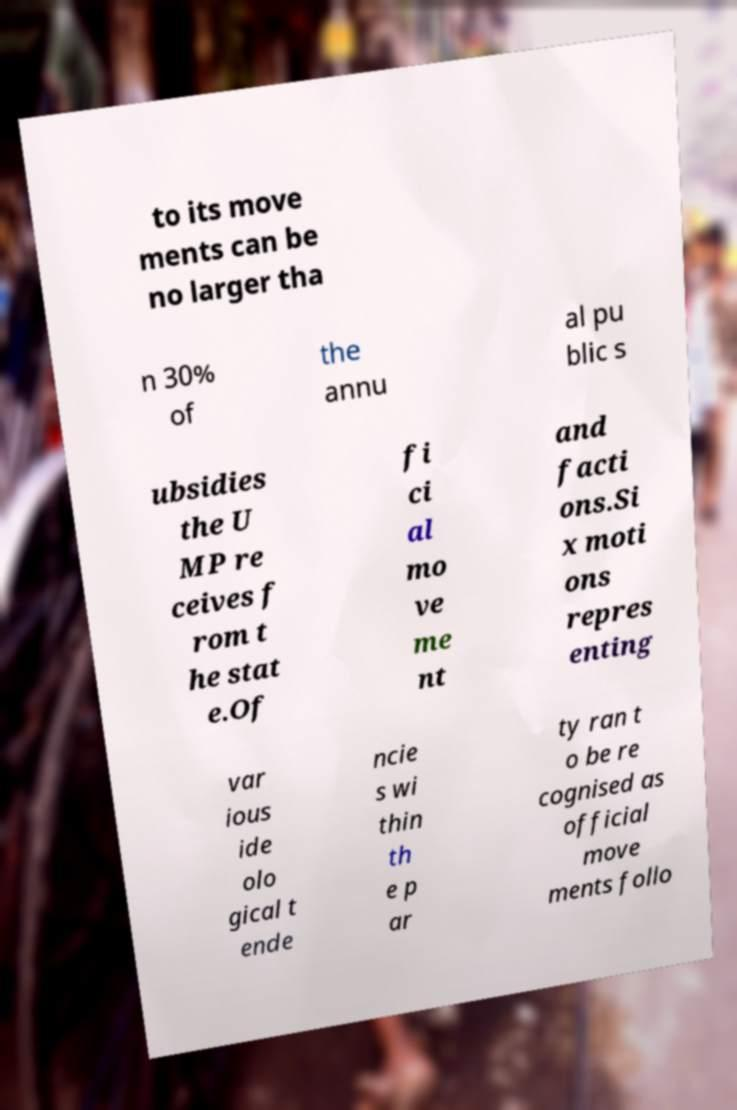Can you accurately transcribe the text from the provided image for me? to its move ments can be no larger tha n 30% of the annu al pu blic s ubsidies the U MP re ceives f rom t he stat e.Of fi ci al mo ve me nt and facti ons.Si x moti ons repres enting var ious ide olo gical t ende ncie s wi thin th e p ar ty ran t o be re cognised as official move ments follo 